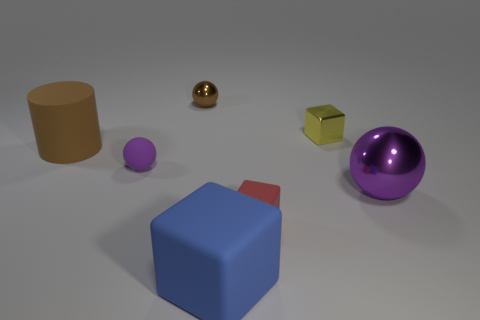Is there anything else that is the same shape as the brown matte object?
Keep it short and to the point. No. There is a large object that is the same color as the rubber sphere; what is it made of?
Offer a terse response. Metal. Is there another object that has the same shape as the large blue matte thing?
Your answer should be very brief. Yes. How many big matte objects have the same shape as the yellow shiny thing?
Provide a short and direct response. 1. Is the color of the tiny rubber sphere the same as the big metal ball?
Provide a short and direct response. Yes. Is the number of small brown balls less than the number of tiny blue blocks?
Your answer should be very brief. No. What is the material of the big thing behind the large purple metal sphere?
Your answer should be compact. Rubber. What is the material of the brown object that is the same size as the purple metallic ball?
Your response must be concise. Rubber. What is the material of the purple thing right of the blue cube that is in front of the big object behind the large metal thing?
Offer a very short reply. Metal. There is a purple thing to the left of the red object; does it have the same size as the tiny red thing?
Provide a short and direct response. Yes. 